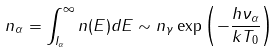Convert formula to latex. <formula><loc_0><loc_0><loc_500><loc_500>n _ { \alpha } = \int _ { I _ { \alpha } } ^ { \infty } n ( E ) d E \sim n _ { \gamma } \exp \left ( - \frac { h \nu _ { \alpha } } { k T _ { 0 } } \right )</formula> 